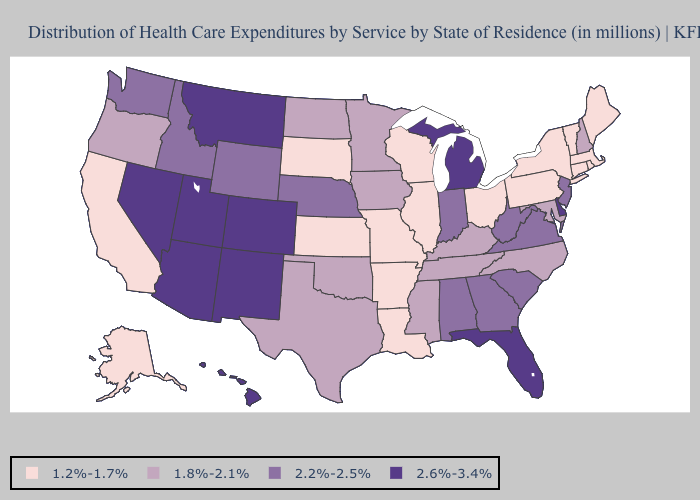Does Montana have the highest value in the USA?
Short answer required. Yes. What is the lowest value in the USA?
Concise answer only. 1.2%-1.7%. What is the highest value in the USA?
Give a very brief answer. 2.6%-3.4%. Name the states that have a value in the range 1.8%-2.1%?
Write a very short answer. Iowa, Kentucky, Maryland, Minnesota, Mississippi, New Hampshire, North Carolina, North Dakota, Oklahoma, Oregon, Tennessee, Texas. Does the map have missing data?
Concise answer only. No. Does Nebraska have the lowest value in the USA?
Answer briefly. No. Does the map have missing data?
Keep it brief. No. Does South Dakota have a lower value than Washington?
Give a very brief answer. Yes. Among the states that border Idaho , which have the lowest value?
Short answer required. Oregon. Does the first symbol in the legend represent the smallest category?
Be succinct. Yes. Which states have the highest value in the USA?
Give a very brief answer. Arizona, Colorado, Delaware, Florida, Hawaii, Michigan, Montana, Nevada, New Mexico, Utah. Name the states that have a value in the range 1.8%-2.1%?
Write a very short answer. Iowa, Kentucky, Maryland, Minnesota, Mississippi, New Hampshire, North Carolina, North Dakota, Oklahoma, Oregon, Tennessee, Texas. What is the value of Wyoming?
Be succinct. 2.2%-2.5%. Does the first symbol in the legend represent the smallest category?
Short answer required. Yes. Does Indiana have the same value as California?
Answer briefly. No. 